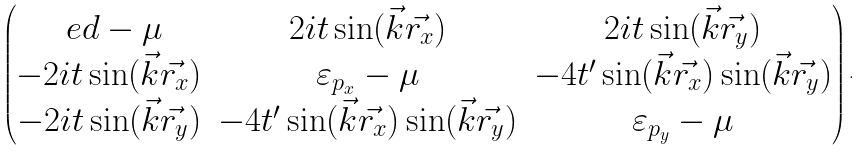Convert formula to latex. <formula><loc_0><loc_0><loc_500><loc_500>\begin{pmatrix} \ e d - \mu & 2 i t \sin ( \vec { k } \vec { r _ { x } } ) & 2 i t \sin ( \vec { k } \vec { r _ { y } } ) \\ - 2 i t \sin ( \vec { k } \vec { r _ { x } } ) & \varepsilon _ { p _ { x } } - \mu & - 4 t ^ { \prime } \sin ( \vec { k } \vec { r _ { x } } ) \sin ( \vec { k } \vec { r _ { y } } ) \\ - 2 i t \sin ( \vec { k } \vec { r _ { y } } ) & - 4 t ^ { \prime } \sin ( \vec { k } \vec { r _ { x } } ) \sin ( \vec { k } \vec { r _ { y } } ) & \varepsilon _ { p _ { y } } - \mu \end{pmatrix} .</formula> 